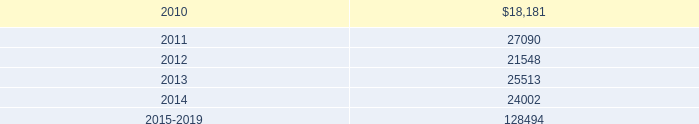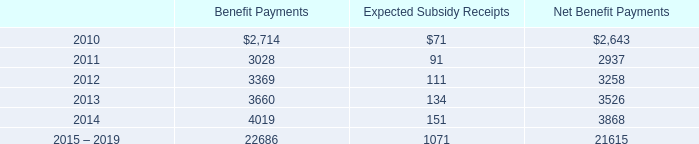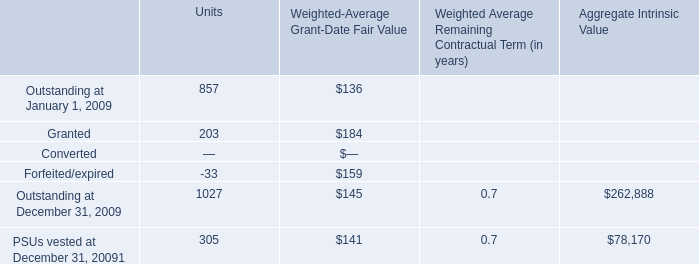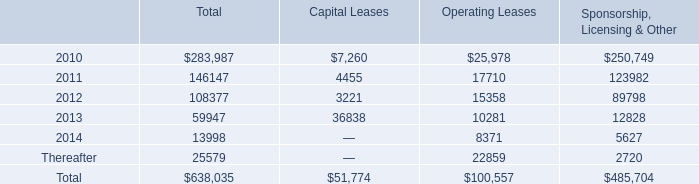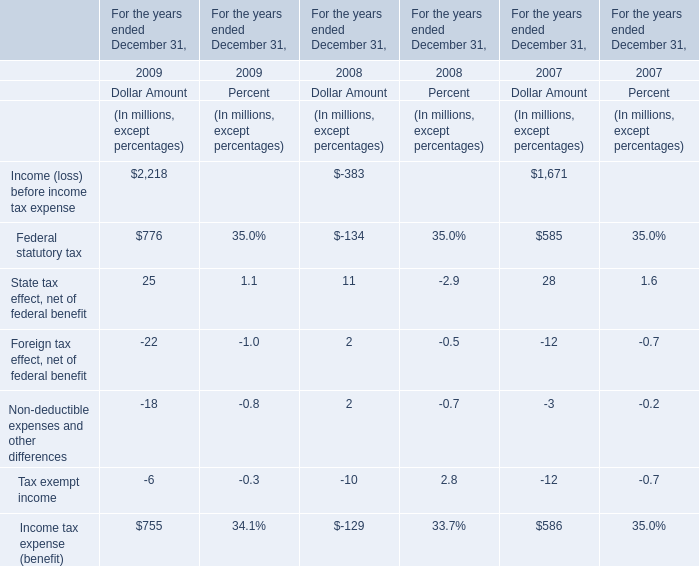What's the greatest value of Dollar Amount in 2009? (in million) 
Answer: 776. 